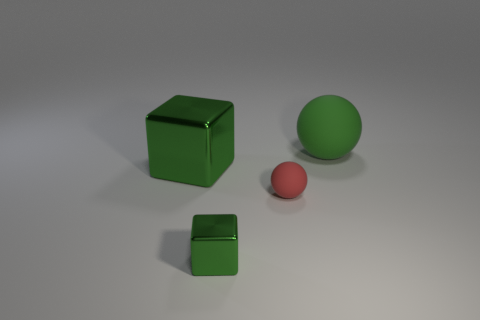Add 1 small gray cylinders. How many objects exist? 5 Subtract 0 purple cubes. How many objects are left? 4 Subtract all big green cubes. Subtract all large metal cubes. How many objects are left? 2 Add 4 red rubber spheres. How many red rubber spheres are left? 5 Add 3 small green blocks. How many small green blocks exist? 4 